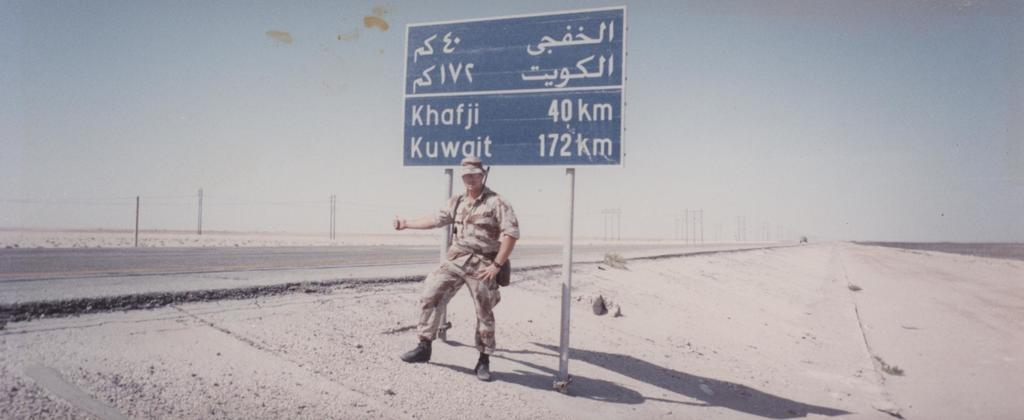<image>
Offer a succinct explanation of the picture presented. a soldier is standing by a sign that says it is 172 miles to Kuwait 